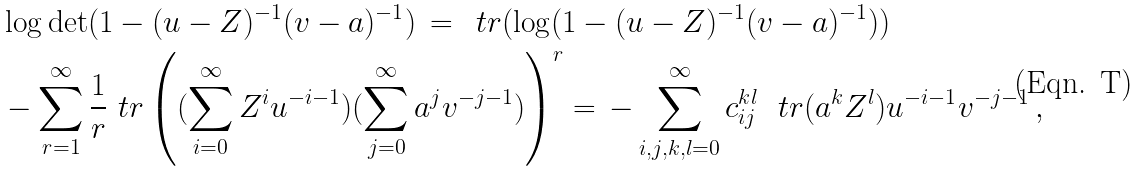<formula> <loc_0><loc_0><loc_500><loc_500>& \log \det ( 1 - ( u - Z ) ^ { - 1 } ( v - \L a ) ^ { - 1 } ) \, = \, \ t r ( \log ( 1 - ( u - Z ) ^ { - 1 } ( v - \L a ) ^ { - 1 } ) ) \, \\ & - \sum _ { r = 1 } ^ { \infty } \frac { 1 } { r } \ t r \left ( ( \sum _ { i = 0 } ^ { \infty } Z ^ { i } u ^ { - i - 1 } ) ( \sum _ { j = 0 } ^ { \infty } \L a ^ { j } v ^ { - j - 1 } ) \right ) ^ { r } = \, - \sum _ { i , j , k , l = 0 } ^ { \infty } c _ { i j } ^ { k l } \ \ t r ( \L a ^ { k } Z ^ { l } ) u ^ { - i - 1 } v ^ { - j - 1 } \, ,</formula> 